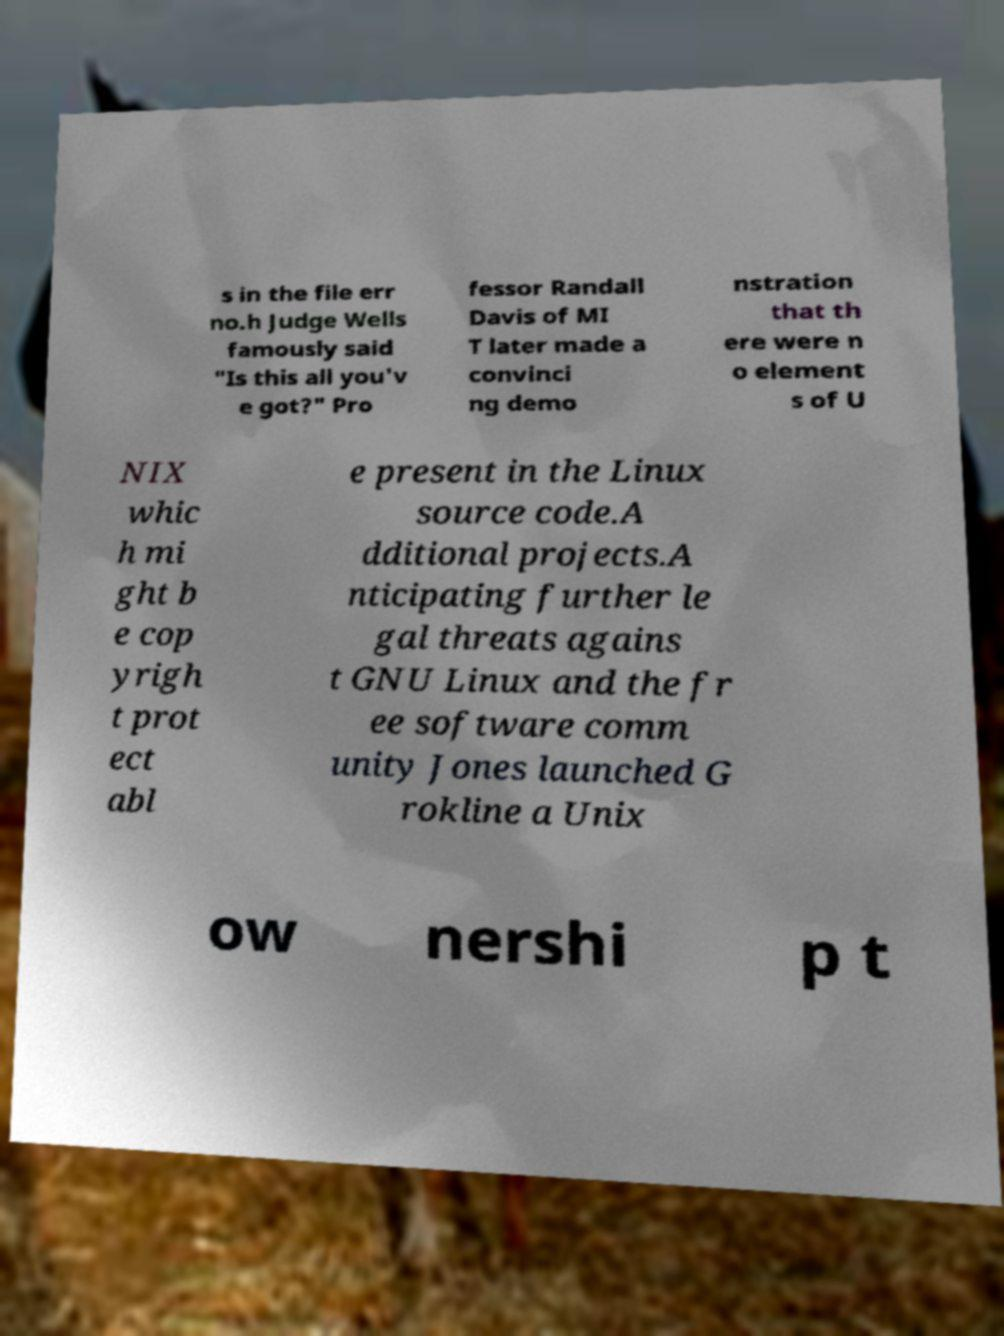I need the written content from this picture converted into text. Can you do that? s in the file err no.h Judge Wells famously said "Is this all you'v e got?" Pro fessor Randall Davis of MI T later made a convinci ng demo nstration that th ere were n o element s of U NIX whic h mi ght b e cop yrigh t prot ect abl e present in the Linux source code.A dditional projects.A nticipating further le gal threats agains t GNU Linux and the fr ee software comm unity Jones launched G rokline a Unix ow nershi p t 